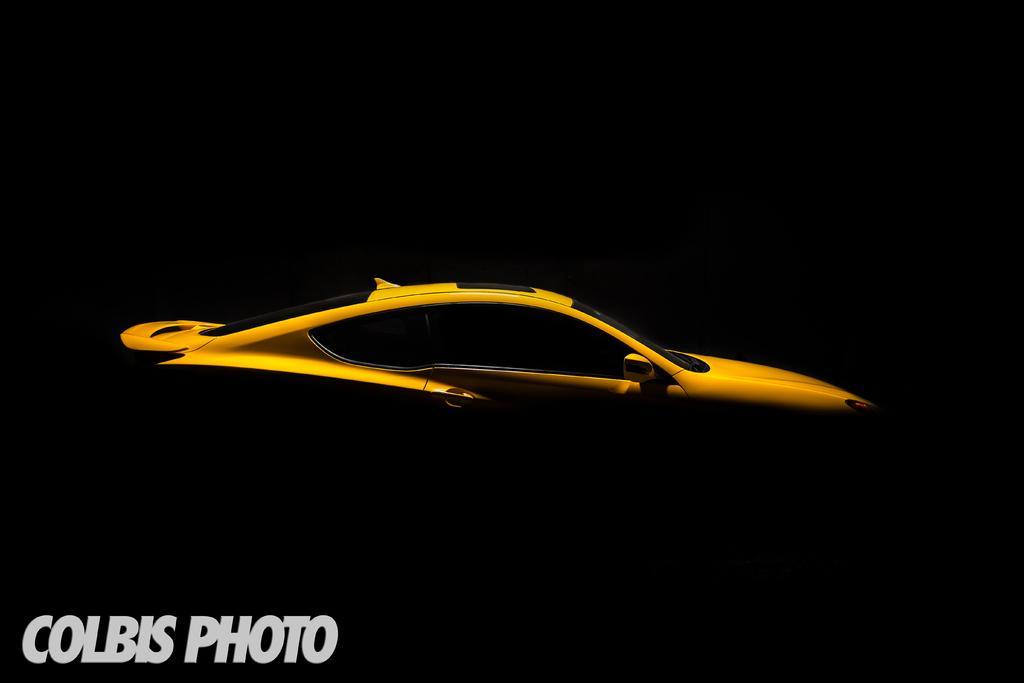Describe this image in one or two sentences. In this picture there is a poster. in the center we can see the yellow car. In bottom left corner there is a watermark. On the top we can see the darkness. 